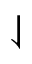Convert formula to latex. <formula><loc_0><loc_0><loc_500><loc_500>\downharpoonleft</formula> 